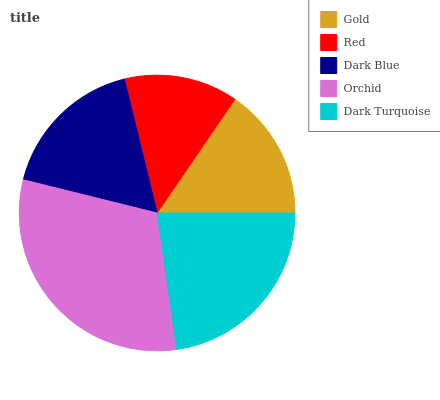Is Red the minimum?
Answer yes or no. Yes. Is Orchid the maximum?
Answer yes or no. Yes. Is Dark Blue the minimum?
Answer yes or no. No. Is Dark Blue the maximum?
Answer yes or no. No. Is Dark Blue greater than Red?
Answer yes or no. Yes. Is Red less than Dark Blue?
Answer yes or no. Yes. Is Red greater than Dark Blue?
Answer yes or no. No. Is Dark Blue less than Red?
Answer yes or no. No. Is Dark Blue the high median?
Answer yes or no. Yes. Is Dark Blue the low median?
Answer yes or no. Yes. Is Gold the high median?
Answer yes or no. No. Is Dark Turquoise the low median?
Answer yes or no. No. 